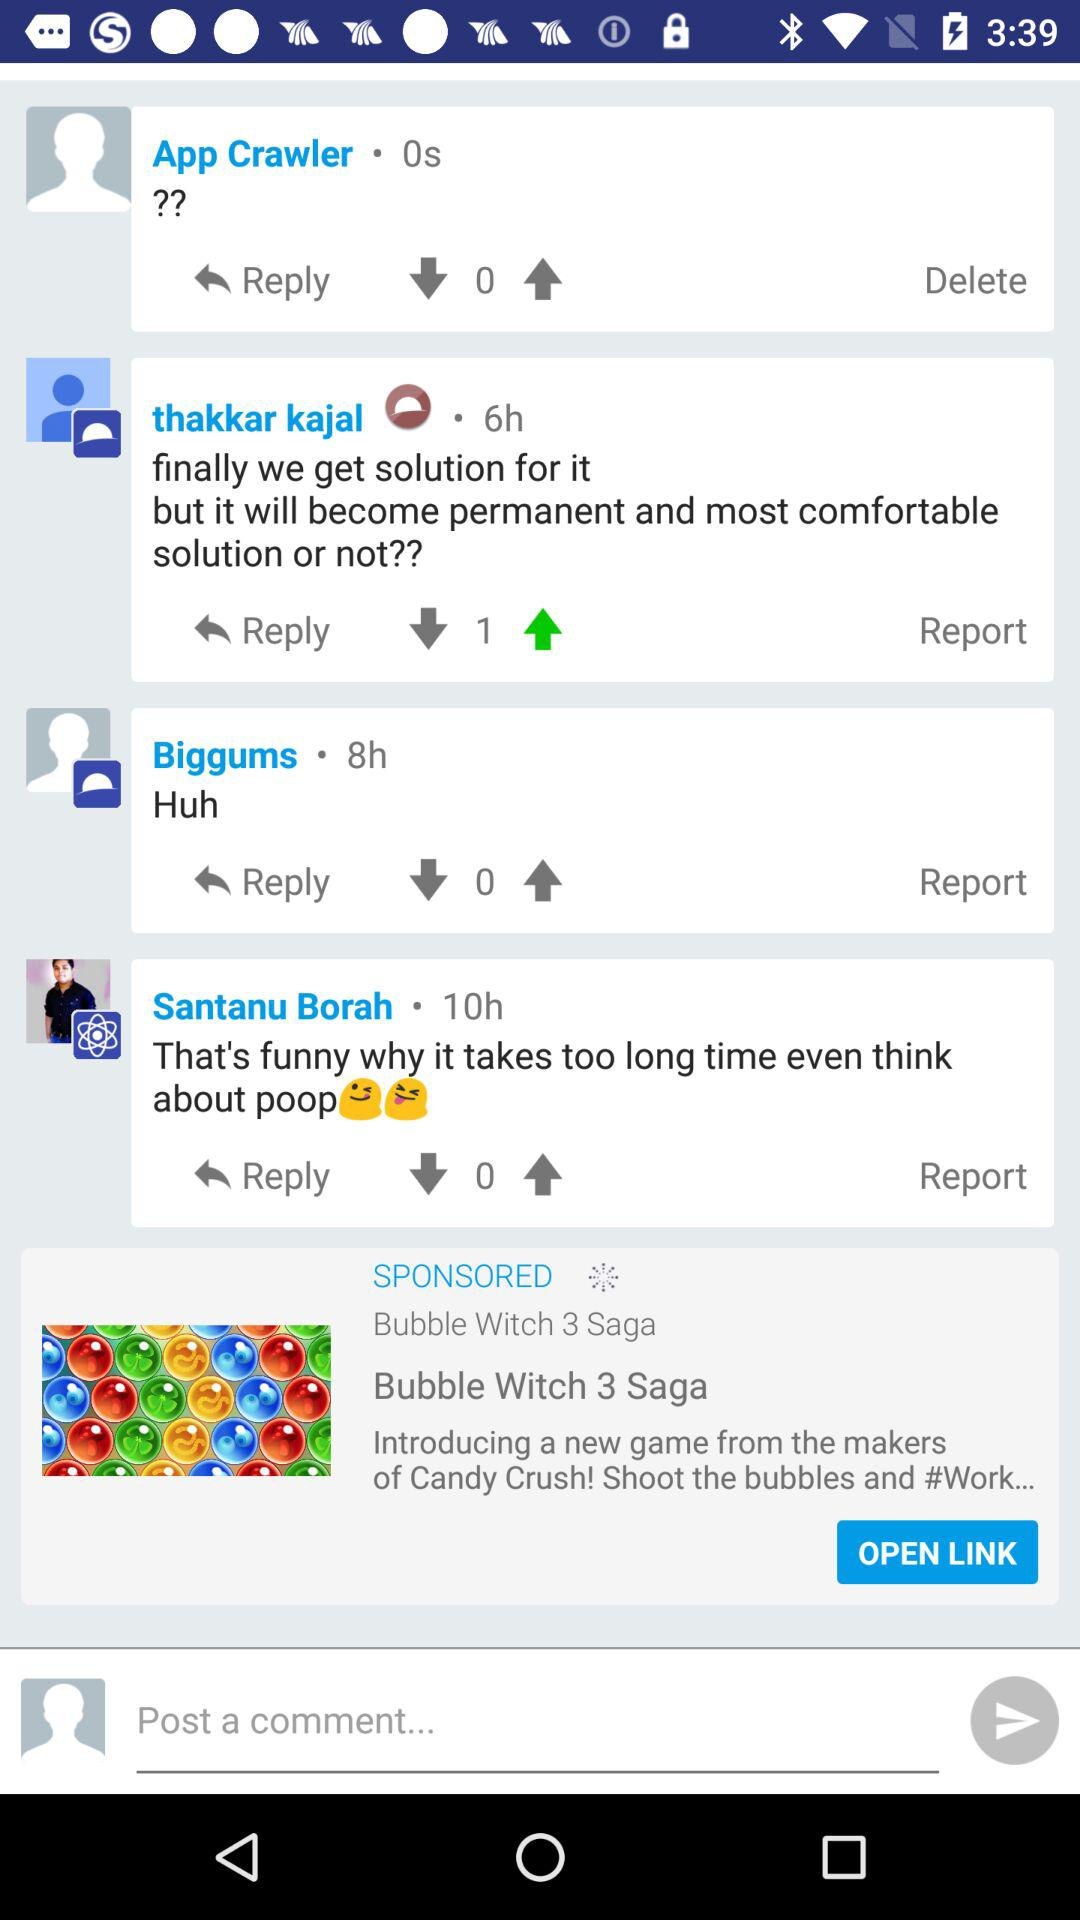How many hours ago did Biggums comment? Biggums commented 8 hours ago. 